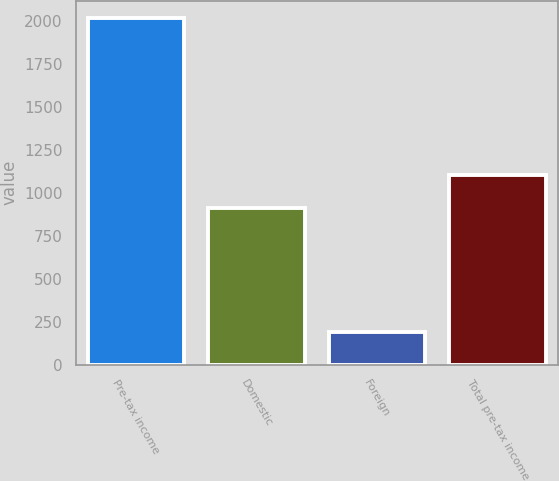<chart> <loc_0><loc_0><loc_500><loc_500><bar_chart><fcel>Pre-tax income<fcel>Domestic<fcel>Foreign<fcel>Total pre-tax income<nl><fcel>2016<fcel>914<fcel>191.5<fcel>1105.5<nl></chart> 